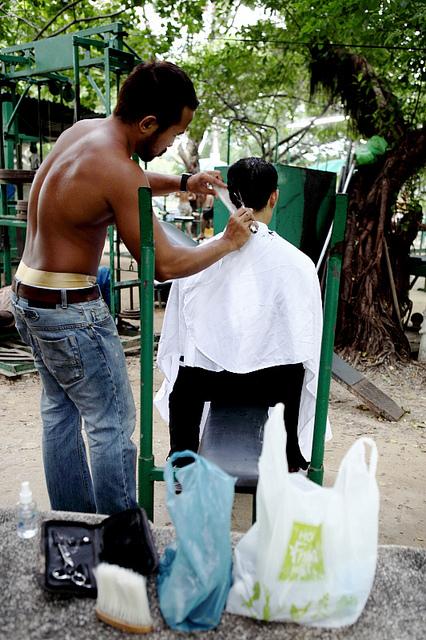What is the man without a shirt doing to the sitting man?
Write a very short answer. Cutting hair. How many bags are there?
Quick response, please. 2. Where is the blue bag?
Answer briefly. On ground. 